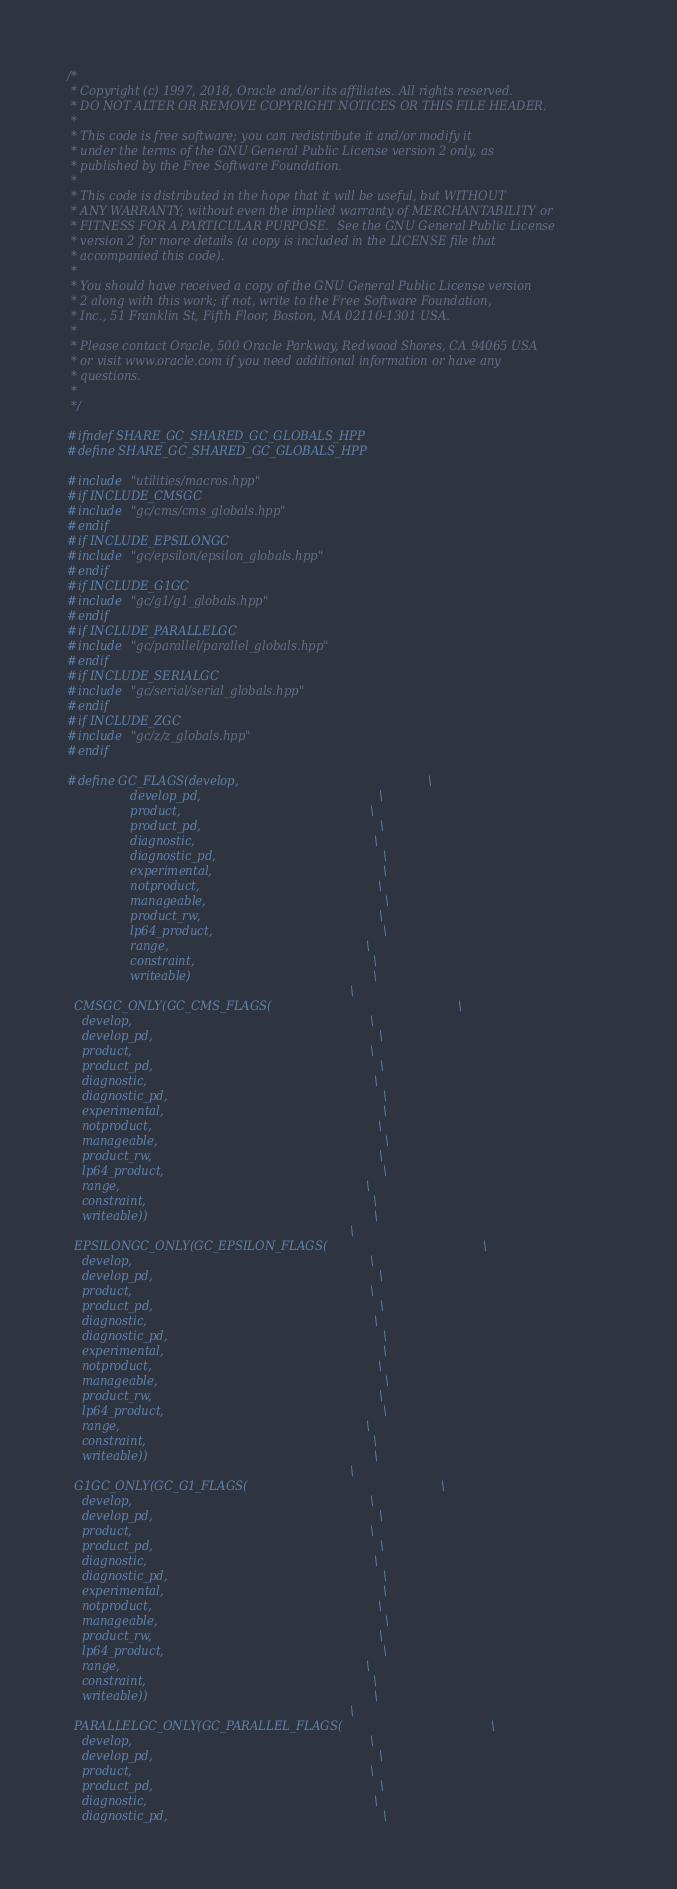Convert code to text. <code><loc_0><loc_0><loc_500><loc_500><_C++_>/*
 * Copyright (c) 1997, 2018, Oracle and/or its affiliates. All rights reserved.
 * DO NOT ALTER OR REMOVE COPYRIGHT NOTICES OR THIS FILE HEADER.
 *
 * This code is free software; you can redistribute it and/or modify it
 * under the terms of the GNU General Public License version 2 only, as
 * published by the Free Software Foundation.
 *
 * This code is distributed in the hope that it will be useful, but WITHOUT
 * ANY WARRANTY; without even the implied warranty of MERCHANTABILITY or
 * FITNESS FOR A PARTICULAR PURPOSE.  See the GNU General Public License
 * version 2 for more details (a copy is included in the LICENSE file that
 * accompanied this code).
 *
 * You should have received a copy of the GNU General Public License version
 * 2 along with this work; if not, write to the Free Software Foundation,
 * Inc., 51 Franklin St, Fifth Floor, Boston, MA 02110-1301 USA.
 *
 * Please contact Oracle, 500 Oracle Parkway, Redwood Shores, CA 94065 USA
 * or visit www.oracle.com if you need additional information or have any
 * questions.
 *
 */

#ifndef SHARE_GC_SHARED_GC_GLOBALS_HPP
#define SHARE_GC_SHARED_GC_GLOBALS_HPP

#include "utilities/macros.hpp"
#if INCLUDE_CMSGC
#include "gc/cms/cms_globals.hpp"
#endif
#if INCLUDE_EPSILONGC
#include "gc/epsilon/epsilon_globals.hpp"
#endif
#if INCLUDE_G1GC
#include "gc/g1/g1_globals.hpp"
#endif
#if INCLUDE_PARALLELGC
#include "gc/parallel/parallel_globals.hpp"
#endif
#if INCLUDE_SERIALGC
#include "gc/serial/serial_globals.hpp"
#endif
#if INCLUDE_ZGC
#include "gc/z/z_globals.hpp"
#endif

#define GC_FLAGS(develop,                                                   \
                 develop_pd,                                                \
                 product,                                                   \
                 product_pd,                                                \
                 diagnostic,                                                \
                 diagnostic_pd,                                             \
                 experimental,                                              \
                 notproduct,                                                \
                 manageable,                                                \
                 product_rw,                                                \
                 lp64_product,                                              \
                 range,                                                     \
                 constraint,                                                \
                 writeable)                                                 \
                                                                            \
  CMSGC_ONLY(GC_CMS_FLAGS(                                                  \
    develop,                                                                \
    develop_pd,                                                             \
    product,                                                                \
    product_pd,                                                             \
    diagnostic,                                                             \
    diagnostic_pd,                                                          \
    experimental,                                                           \
    notproduct,                                                             \
    manageable,                                                             \
    product_rw,                                                             \
    lp64_product,                                                           \
    range,                                                                  \
    constraint,                                                             \
    writeable))                                                             \
                                                                            \
  EPSILONGC_ONLY(GC_EPSILON_FLAGS(                                          \
    develop,                                                                \
    develop_pd,                                                             \
    product,                                                                \
    product_pd,                                                             \
    diagnostic,                                                             \
    diagnostic_pd,                                                          \
    experimental,                                                           \
    notproduct,                                                             \
    manageable,                                                             \
    product_rw,                                                             \
    lp64_product,                                                           \
    range,                                                                  \
    constraint,                                                             \
    writeable))                                                             \
                                                                            \
  G1GC_ONLY(GC_G1_FLAGS(                                                    \
    develop,                                                                \
    develop_pd,                                                             \
    product,                                                                \
    product_pd,                                                             \
    diagnostic,                                                             \
    diagnostic_pd,                                                          \
    experimental,                                                           \
    notproduct,                                                             \
    manageable,                                                             \
    product_rw,                                                             \
    lp64_product,                                                           \
    range,                                                                  \
    constraint,                                                             \
    writeable))                                                             \
                                                                            \
  PARALLELGC_ONLY(GC_PARALLEL_FLAGS(                                        \
    develop,                                                                \
    develop_pd,                                                             \
    product,                                                                \
    product_pd,                                                             \
    diagnostic,                                                             \
    diagnostic_pd,                                                          \</code> 